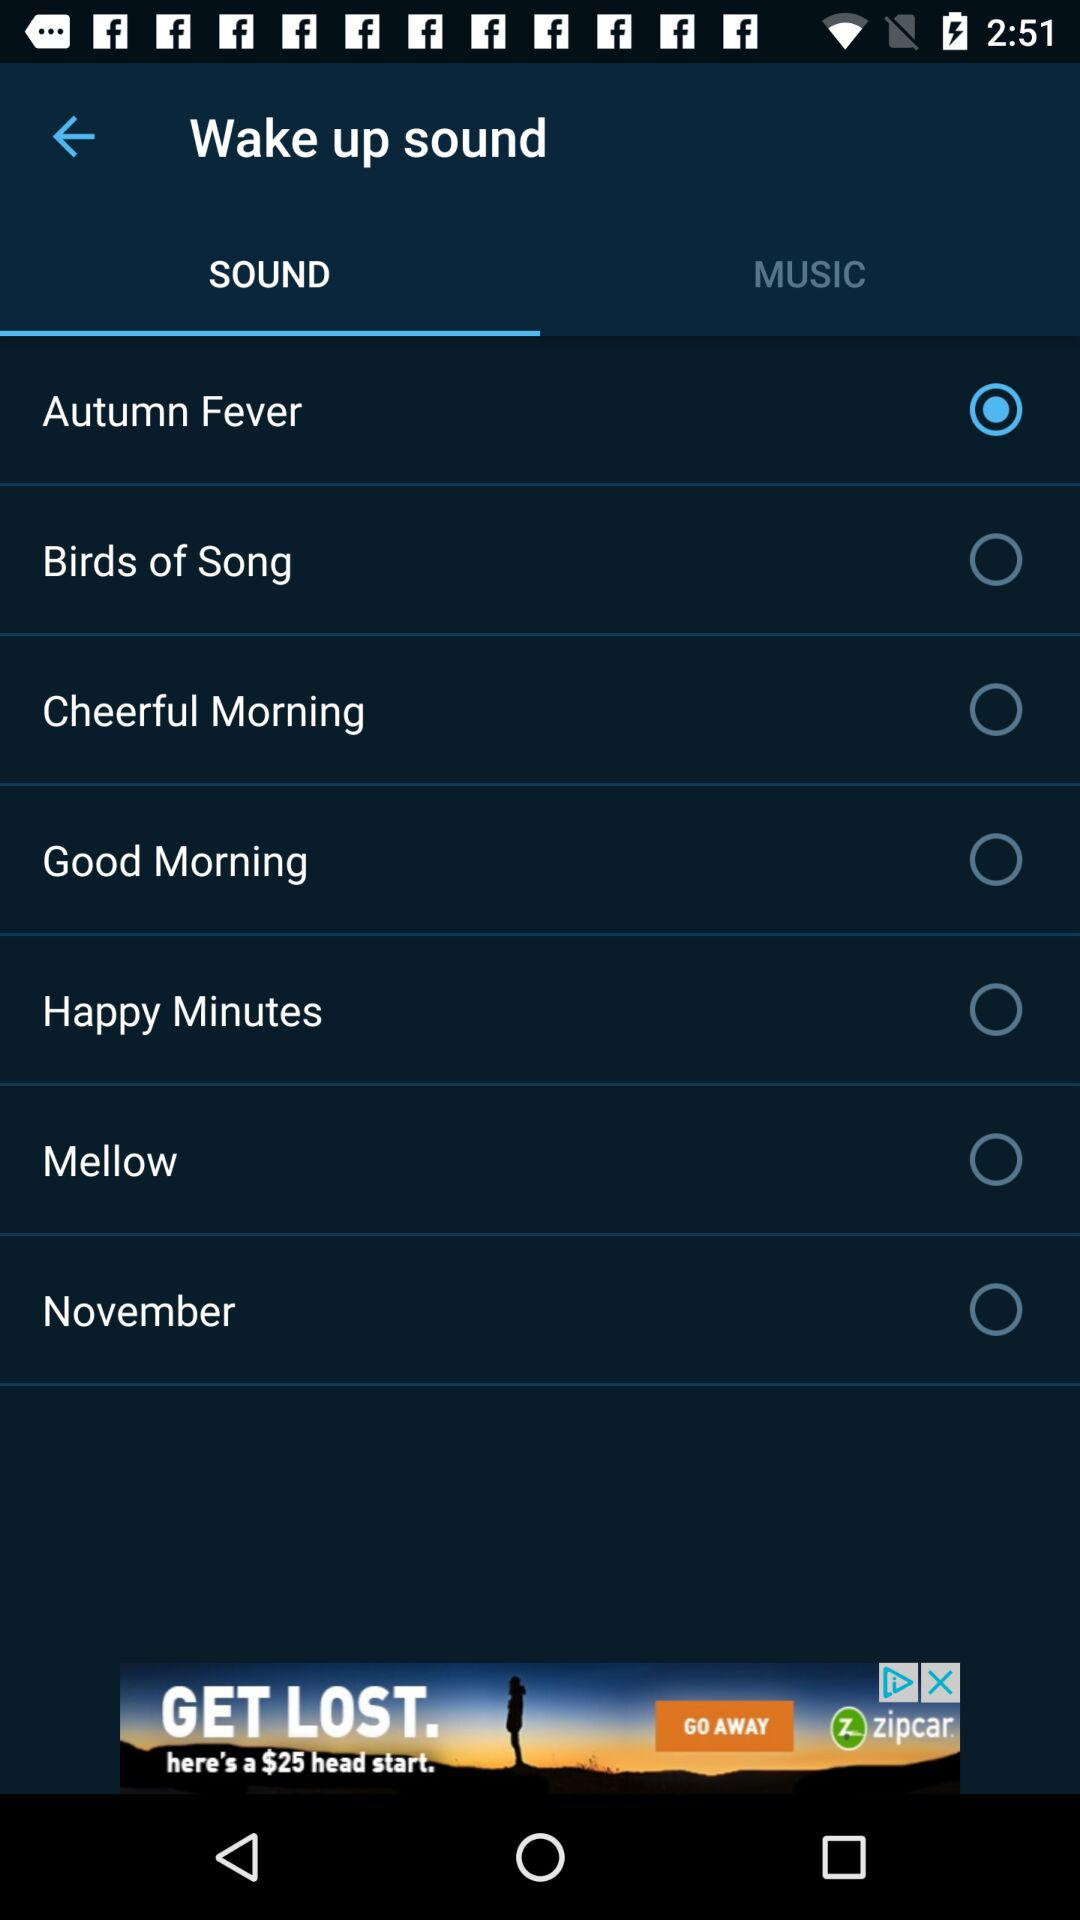Which tab is selected? The selected tab is "SOUND". 